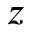<formula> <loc_0><loc_0><loc_500><loc_500>z</formula> 